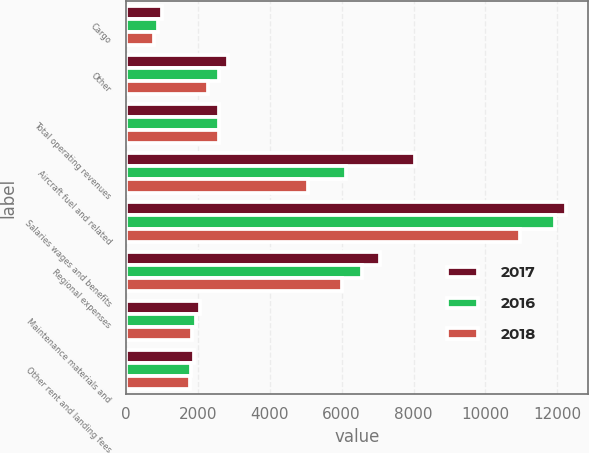Convert chart. <chart><loc_0><loc_0><loc_500><loc_500><stacked_bar_chart><ecel><fcel>Cargo<fcel>Other<fcel>Total operating revenues<fcel>Aircraft fuel and related<fcel>Salaries wages and benefits<fcel>Regional expenses<fcel>Maintenance materials and<fcel>Other rent and landing fees<nl><fcel>2017<fcel>1013<fcel>2841<fcel>2589<fcel>8053<fcel>12240<fcel>7064<fcel>2050<fcel>1900<nl><fcel>2016<fcel>890<fcel>2589<fcel>2589<fcel>6128<fcel>11942<fcel>6572<fcel>1959<fcel>1806<nl><fcel>2018<fcel>785<fcel>2295<fcel>2589<fcel>5071<fcel>10958<fcel>6009<fcel>1834<fcel>1772<nl></chart> 